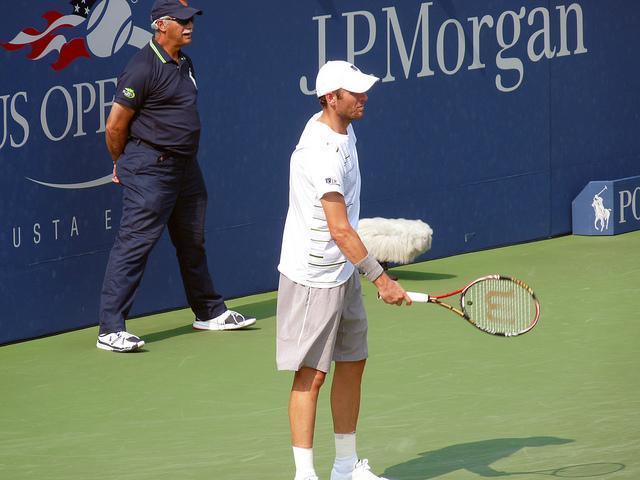How many men are in the picture?
Give a very brief answer. 2. How many people can you see?
Give a very brief answer. 2. 